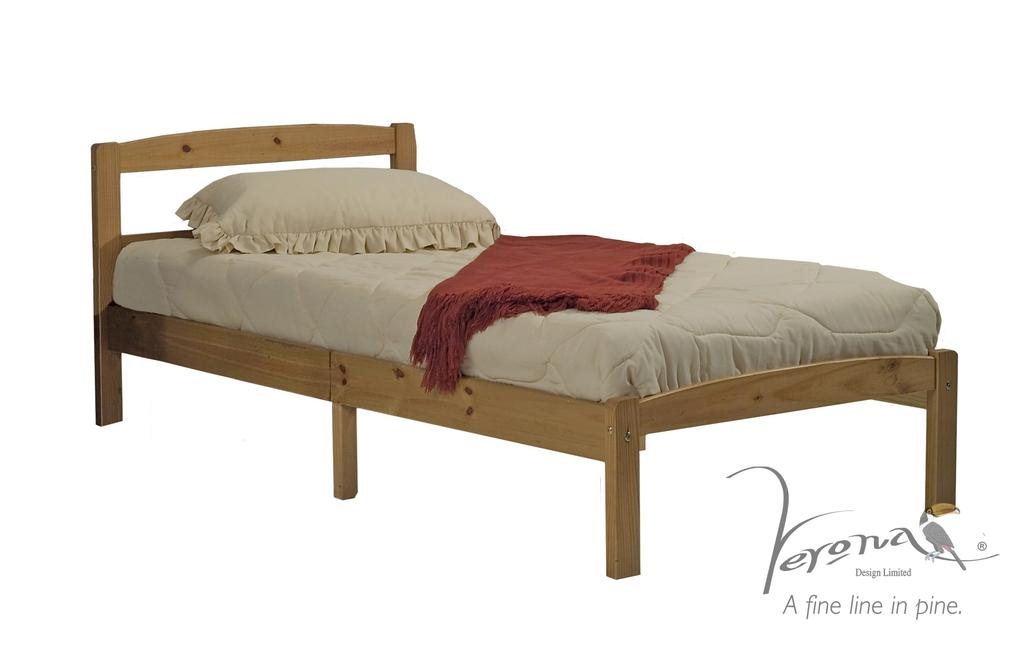What piece of furniture is present in the image? There is a bed in the image. What is placed on the bed? There is a pillow and cloth on the bed. What color is the background of the image? The background of the image is white. Where can text be found in the image? Text is visible in the bottom right corner of the image. How many members are on the team that is playing in the image? There is no team or any indication of a game present in the image; it only features a bed with a pillow and cloth. 